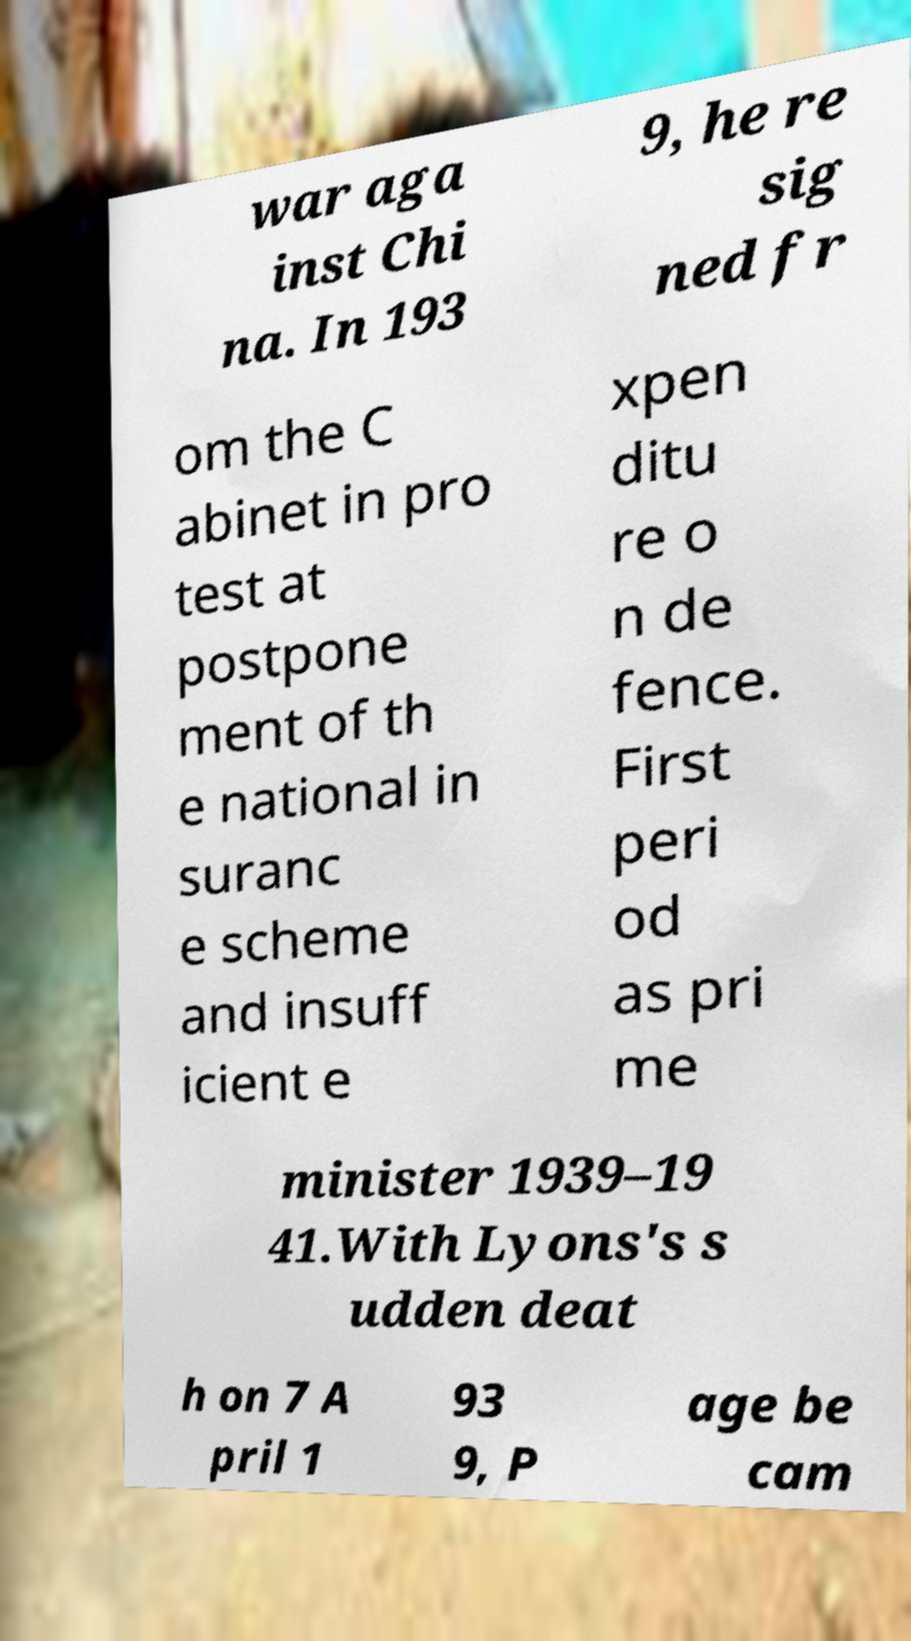I need the written content from this picture converted into text. Can you do that? war aga inst Chi na. In 193 9, he re sig ned fr om the C abinet in pro test at postpone ment of th e national in suranc e scheme and insuff icient e xpen ditu re o n de fence. First peri od as pri me minister 1939–19 41.With Lyons's s udden deat h on 7 A pril 1 93 9, P age be cam 